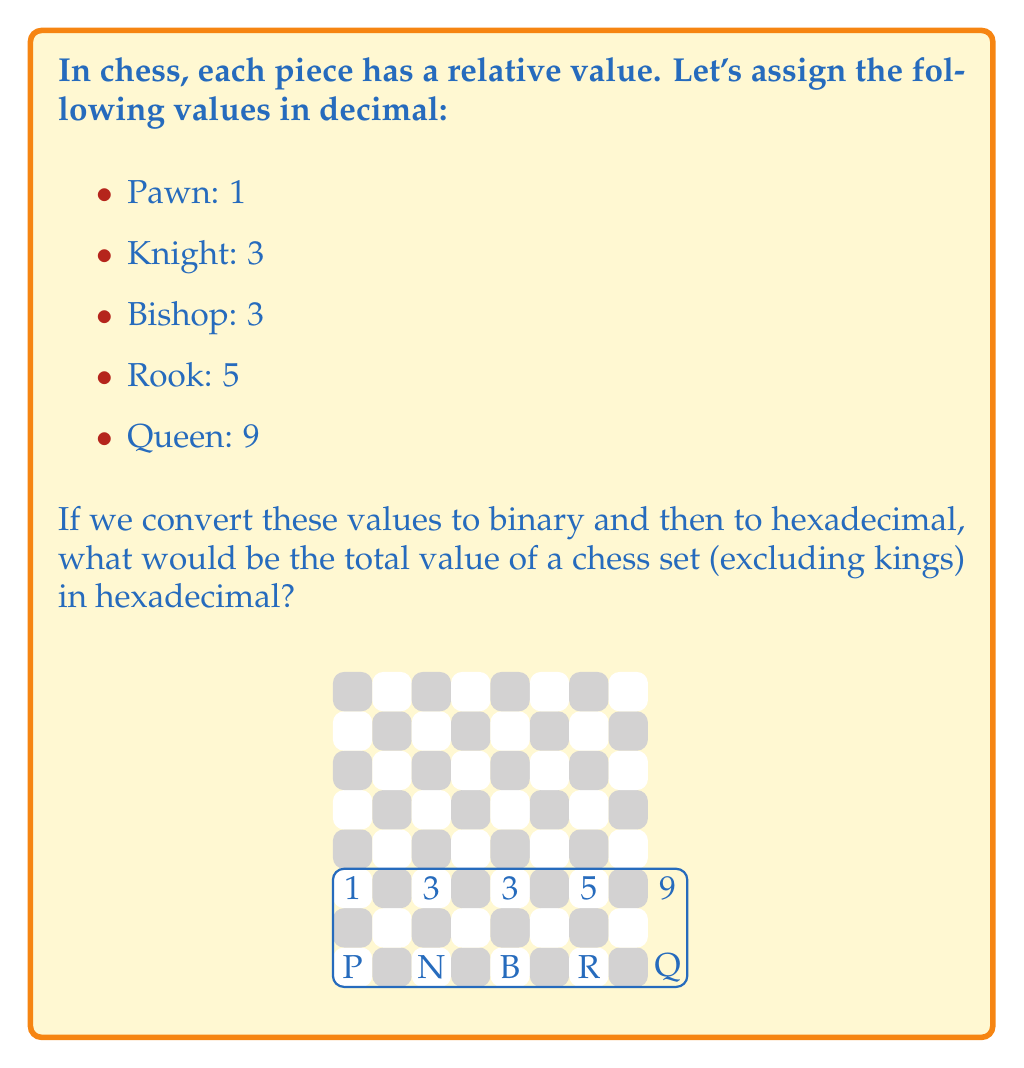Solve this math problem. Let's approach this step-by-step:

1) First, let's count the pieces in a chess set (excluding kings):
   - 8 pawns
   - 2 knights
   - 2 bishops
   - 2 rooks
   - 1 queen

2) Now, let's calculate the total value in decimal:
   $$(8 \times 1) + (2 \times 3) + (2 \times 3) + (2 \times 5) + (1 \times 9) = 8 + 6 + 6 + 10 + 9 = 39$$

3) Convert 39 to binary:
   $39_{10} = 100111_2$

4) Convert binary to hexadecimal:
   $100111_2 = 27_{16}$

Therefore, the total value of a chess set (excluding kings) in hexadecimal is $27_{16}$.
Answer: $27_{16}$ 